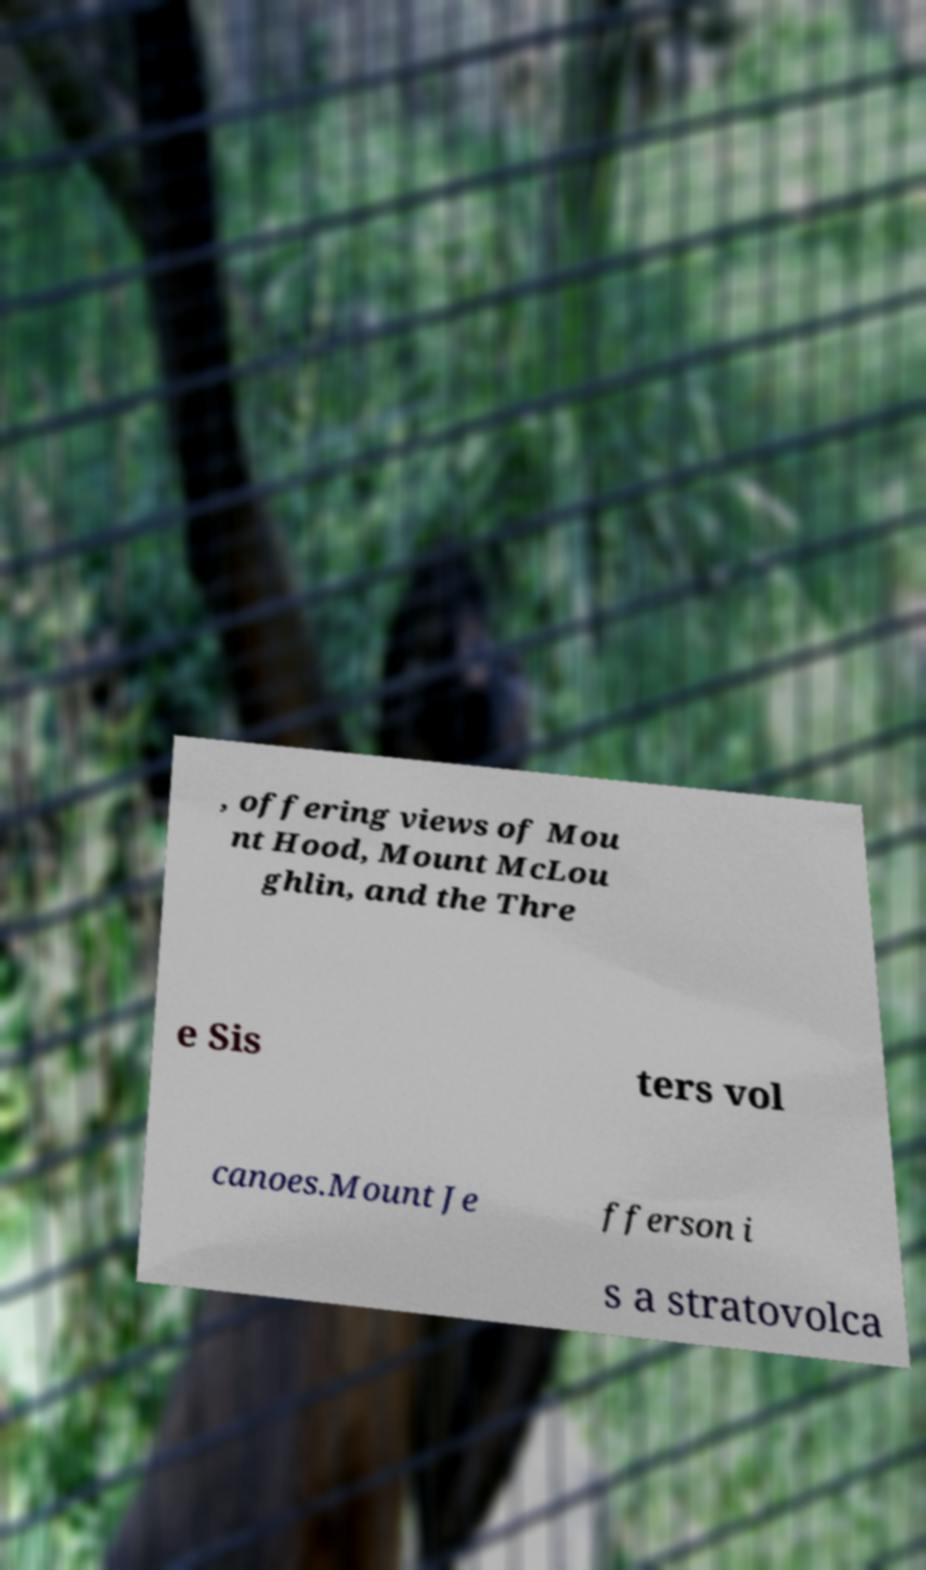I need the written content from this picture converted into text. Can you do that? , offering views of Mou nt Hood, Mount McLou ghlin, and the Thre e Sis ters vol canoes.Mount Je fferson i s a stratovolca 